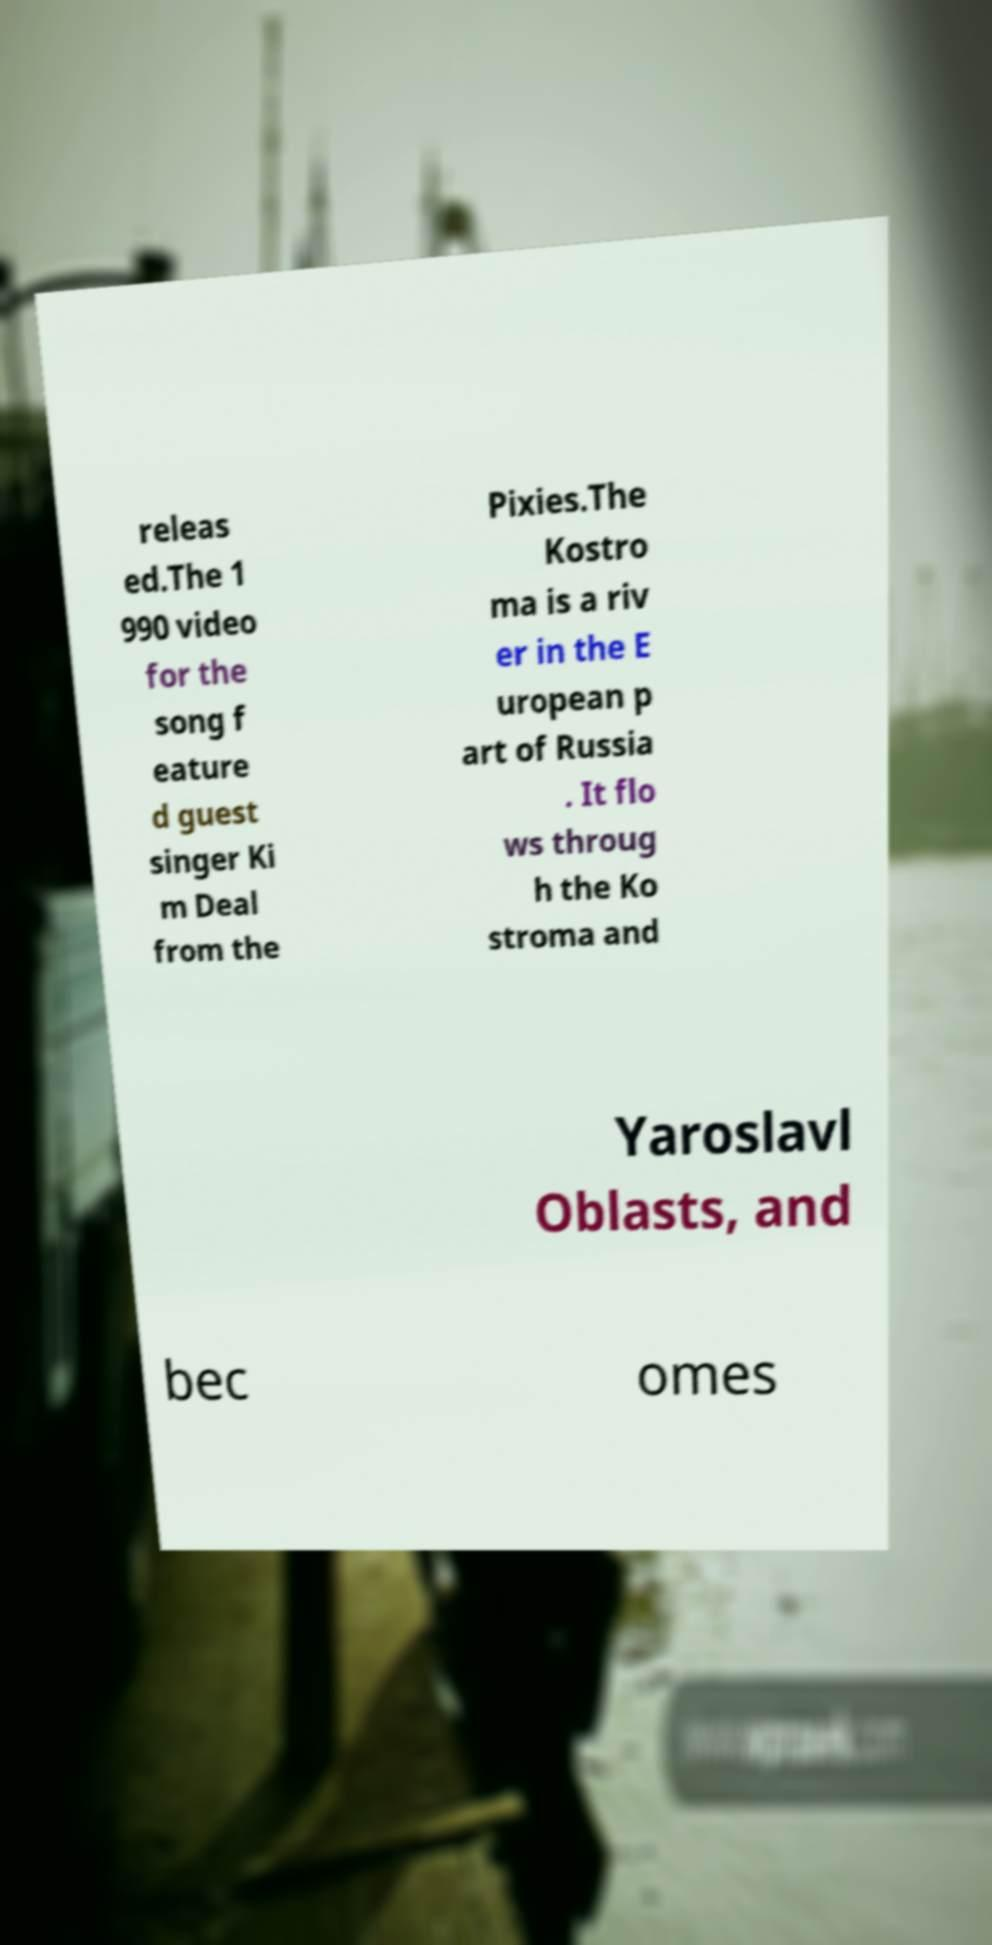Please read and relay the text visible in this image. What does it say? releas ed.The 1 990 video for the song f eature d guest singer Ki m Deal from the Pixies.The Kostro ma is a riv er in the E uropean p art of Russia . It flo ws throug h the Ko stroma and Yaroslavl Oblasts, and bec omes 